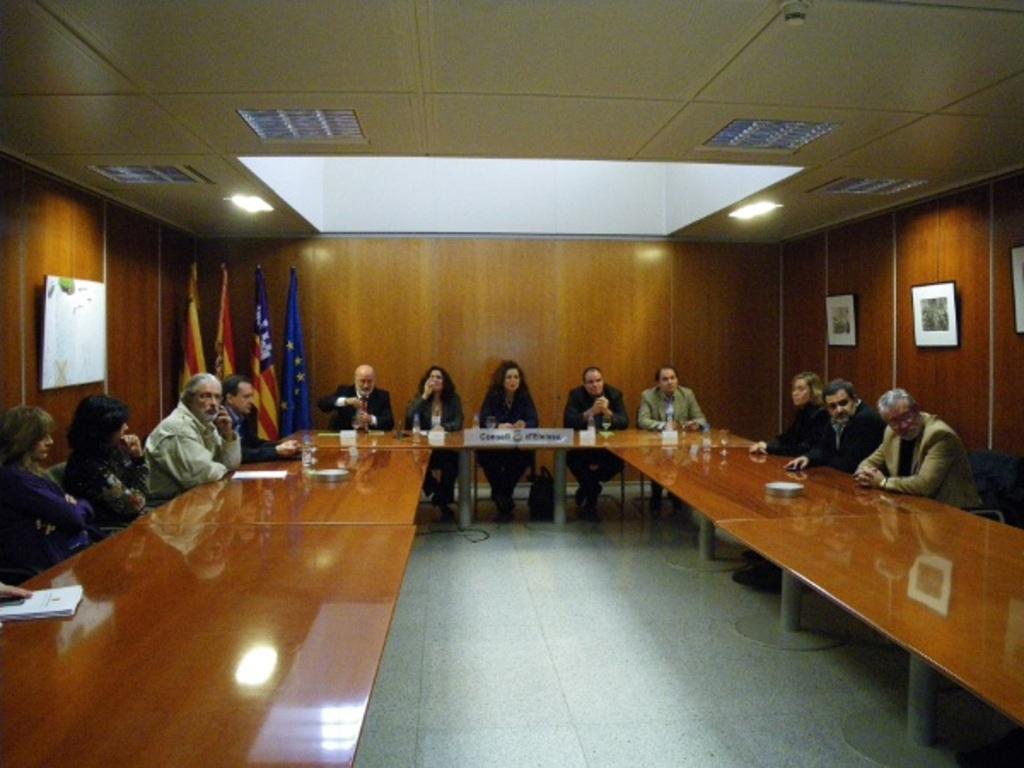Can you describe this image briefly? In the center of the image we can see few people are sitting on the chairs around the table. On the table we can see papers,water bottles,glasses and few other objects. In the background there is a wall,photo frames,flags,one board,lights etc. 